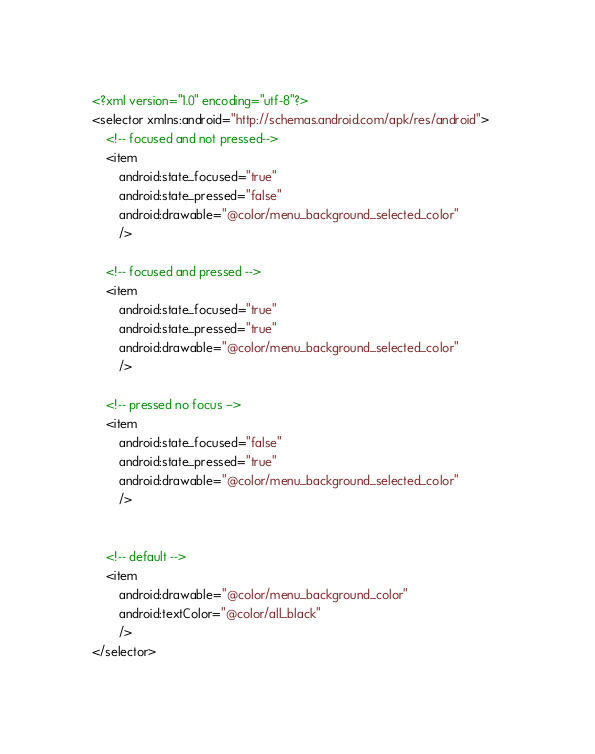Convert code to text. <code><loc_0><loc_0><loc_500><loc_500><_XML_><?xml version="1.0" encoding="utf-8"?>
<selector xmlns:android="http://schemas.android.com/apk/res/android">    
    <!-- focused and not pressed-->		
	<item 
		android:state_focused="true" 
		android:state_pressed="false"
		android:drawable="@color/menu_background_selected_color" 
		/>
		
	<!-- focused and pressed -->				
	<item 
		android:state_focused="true" 
		android:state_pressed="true"
		android:drawable="@color/menu_background_selected_color" 
		/>

	<!-- pressed no focus -->		
	<item 
		android:state_focused="false" 
		android:state_pressed="true"
		android:drawable="@color/menu_background_selected_color" 
		/>


	<!-- default -->		
	<item 
		android:drawable="@color/menu_background_color" 
		android:textColor="@color/all_black"
		/>
</selector>
</code> 